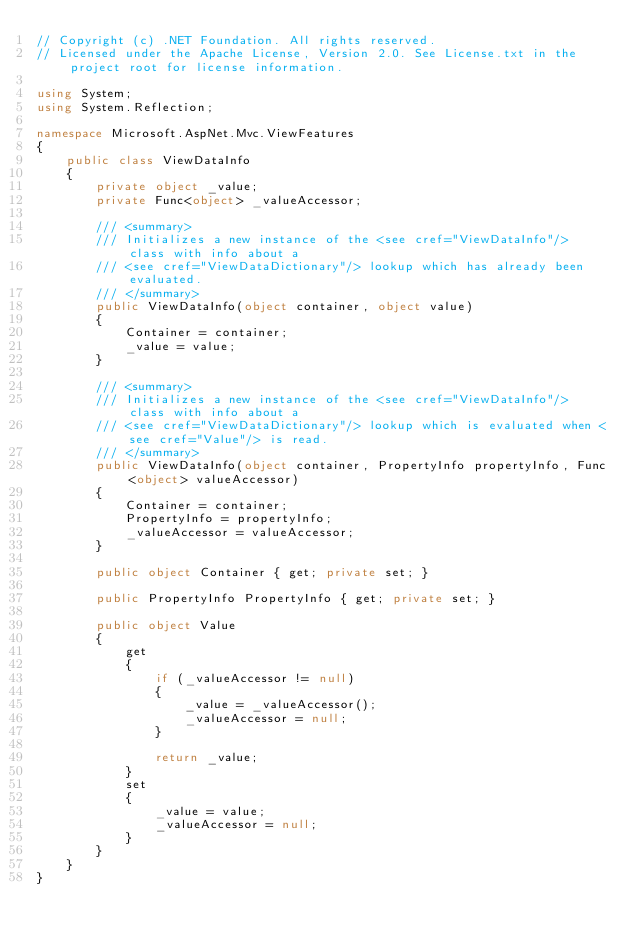Convert code to text. <code><loc_0><loc_0><loc_500><loc_500><_C#_>// Copyright (c) .NET Foundation. All rights reserved.
// Licensed under the Apache License, Version 2.0. See License.txt in the project root for license information.

using System;
using System.Reflection;

namespace Microsoft.AspNet.Mvc.ViewFeatures
{
    public class ViewDataInfo
    {
        private object _value;
        private Func<object> _valueAccessor;

        /// <summary>
        /// Initializes a new instance of the <see cref="ViewDataInfo"/> class with info about a
        /// <see cref="ViewDataDictionary"/> lookup which has already been evaluated.
        /// </summary>
        public ViewDataInfo(object container, object value)
        {
            Container = container;
            _value = value;
        }

        /// <summary>
        /// Initializes a new instance of the <see cref="ViewDataInfo"/> class with info about a
        /// <see cref="ViewDataDictionary"/> lookup which is evaluated when <see cref="Value"/> is read.
        /// </summary>
        public ViewDataInfo(object container, PropertyInfo propertyInfo, Func<object> valueAccessor)
        {
            Container = container;
            PropertyInfo = propertyInfo;
            _valueAccessor = valueAccessor;
        }

        public object Container { get; private set; }

        public PropertyInfo PropertyInfo { get; private set; }

        public object Value
        {
            get
            {
                if (_valueAccessor != null)
                {
                    _value = _valueAccessor();
                    _valueAccessor = null;
                }

                return _value;
            }
            set
            {
                _value = value;
                _valueAccessor = null;
            }
        }
    }
}
</code> 